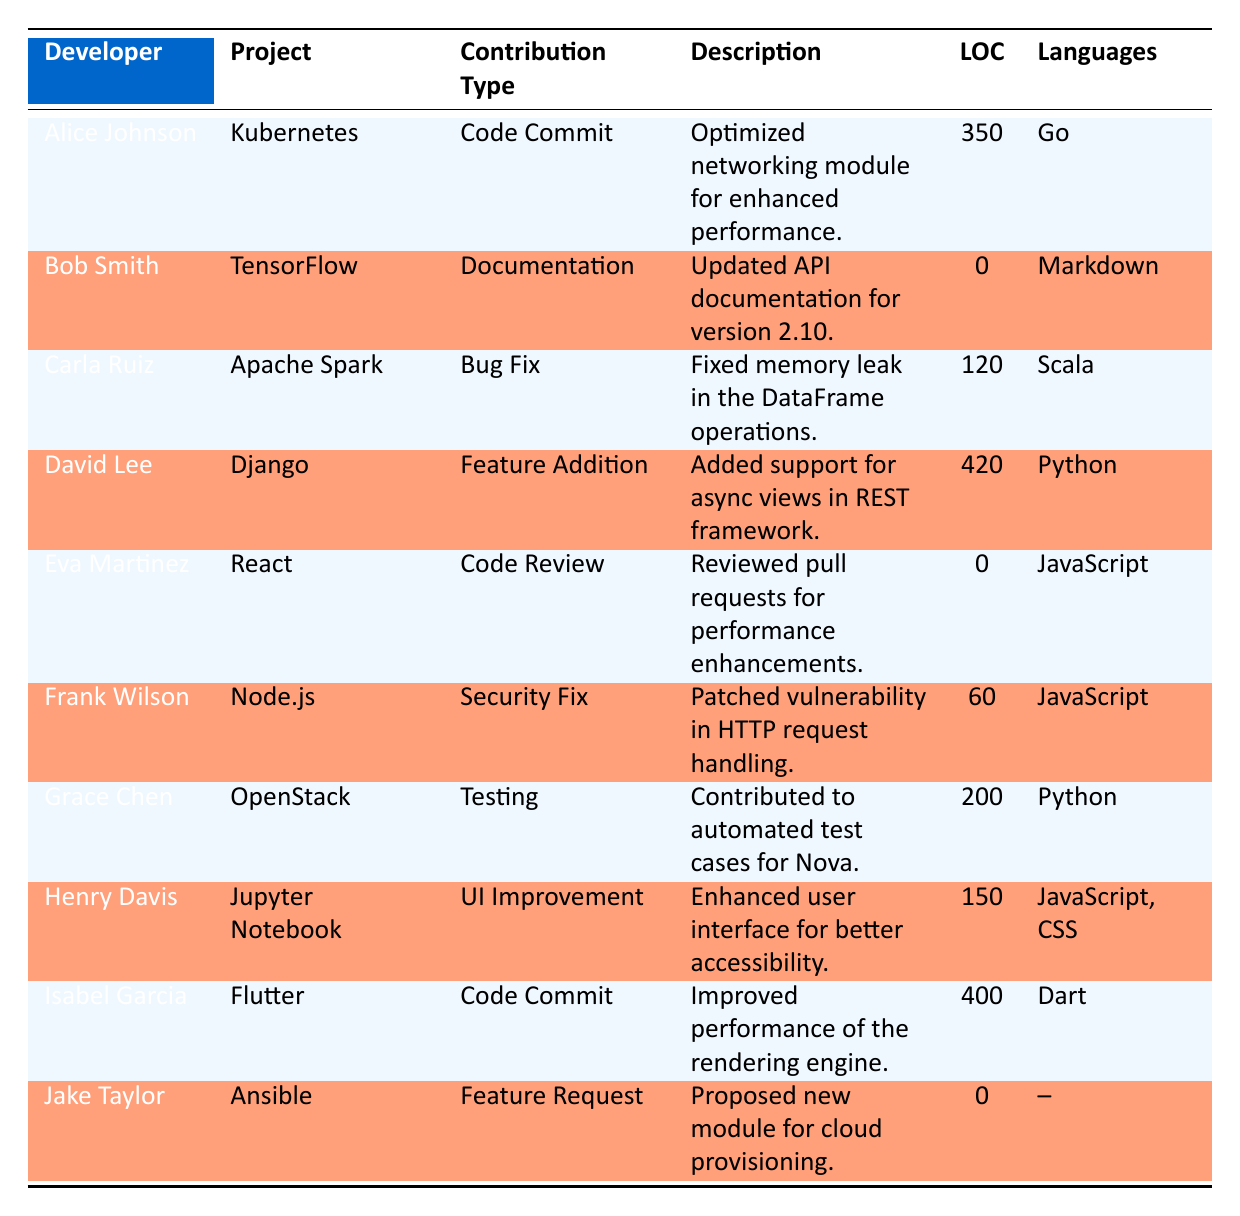What is the total number of lines of code contributed by the developers? To find the total lines of code, sum the LOC values from each row: 350 (Alice) + 0 (Bob) + 120 (Carla) + 420 (David) + 0 (Eva) + 60 (Frank) + 200 (Grace) + 150 (Henry) + 400 (Isabel) + 0 (Jake) = 1,400.
Answer: 1,400 Which developer contributed to the Apache Spark project? By scanning the project column, Carla Ruiz is listed as the developer who contributed to the Apache Spark project.
Answer: Carla Ruiz Did any developer contribute to both documentation and code commits? Bob Smith contributed to documentation, and Alice Johnson contributed to a code commit; thus, individual contributions are documented but not by the same developer.
Answer: No What is the contribution type with the highest lines of code? The highest lines of code are from David Lee with 420 LOC for feature addition. Therefore, the contribution type with the highest LOC is feature addition.
Answer: Feature Addition Which language was used by the most developers in their contributions? By reviewing the languages used, Go, Markdown, Scala, Python, JavaScript, and Dart are mentioned. The most commonly used languages are JavaScript (used by Eva and Henry), which means it has the most individual contributions.
Answer: JavaScript Is there any project in which no lines of code were contributed? Projects such as TensorFlow and Ansible have contributions that show zero lines of code. Therefore, yes, there are projects without code contributions.
Answer: Yes What is the total number of contributions made by developers for the React project? Eva Martinez contributed code review with 0 LOC, making it the only contribution associated with the React project. Therefore, there is one contribution to the React project.
Answer: 1 How many bug fixes were contributed among the listed projects? From the table, there is one bug fix contributed by Carla Ruiz to Apache Spark. Thus, there is only one bug fix in the listed contributions.
Answer: 1 Which developer made a security fix, and to which project? By reviewing the table, Frank Wilson is identified as the developer who made a security fix for the Node.js project.
Answer: Frank Wilson, Node.js 